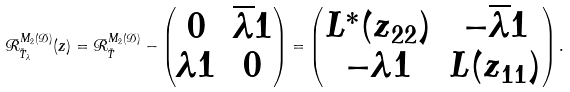Convert formula to latex. <formula><loc_0><loc_0><loc_500><loc_500>\mathcal { R } _ { \tilde { T } _ { \lambda } } ^ { M _ { 2 } ( \mathcal { D } ) } ( z ) = \mathcal { R } _ { \tilde { T } } ^ { M _ { 2 } ( \mathcal { D } ) } - \begin{pmatrix} 0 & \overline { \lambda } 1 \\ \lambda 1 & 0 \end{pmatrix} = \begin{pmatrix} L ^ { * } ( z _ { 2 2 } ) & - \overline { \lambda } 1 \\ - \lambda 1 & L ( z _ { 1 1 } ) \end{pmatrix} .</formula> 